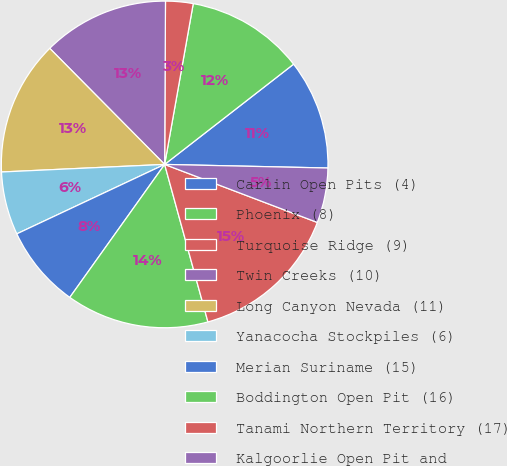Convert chart to OTSL. <chart><loc_0><loc_0><loc_500><loc_500><pie_chart><fcel>Carlin Open Pits (4)<fcel>Phoenix (8)<fcel>Turquoise Ridge (9)<fcel>Twin Creeks (10)<fcel>Long Canyon Nevada (11)<fcel>Yanacocha Stockpiles (6)<fcel>Merian Suriname (15)<fcel>Boddington Open Pit (16)<fcel>Tanami Northern Territory (17)<fcel>Kalgoorlie Open Pit and<nl><fcel>10.87%<fcel>11.68%<fcel>2.72%<fcel>12.5%<fcel>13.32%<fcel>6.25%<fcel>8.15%<fcel>14.13%<fcel>14.95%<fcel>5.43%<nl></chart> 